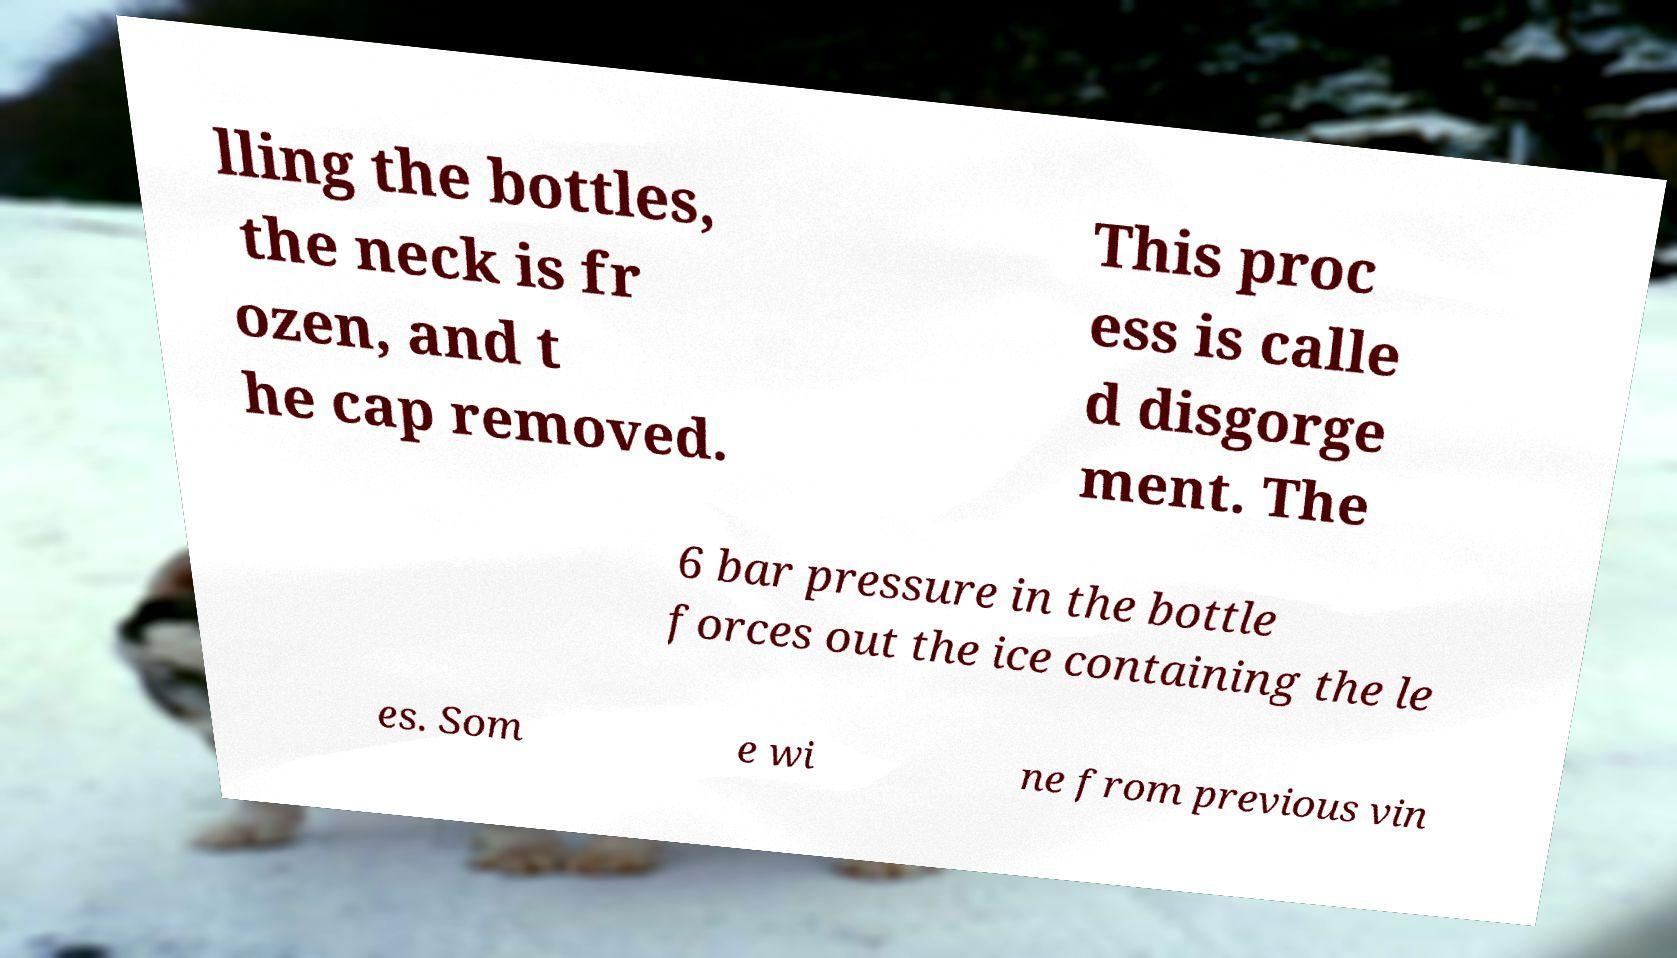Can you accurately transcribe the text from the provided image for me? lling the bottles, the neck is fr ozen, and t he cap removed. This proc ess is calle d disgorge ment. The 6 bar pressure in the bottle forces out the ice containing the le es. Som e wi ne from previous vin 